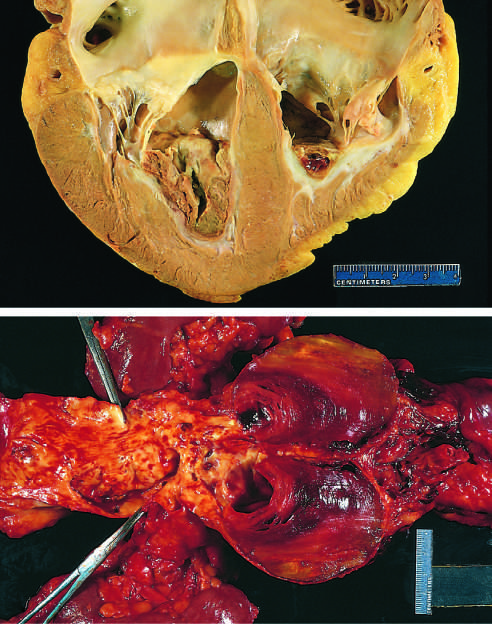re numerous friable mural thrombi super-imposed on advanced atherosclerotic lesions of the more proximal aorta (left side of photograph)?
Answer the question using a single word or phrase. Yes 